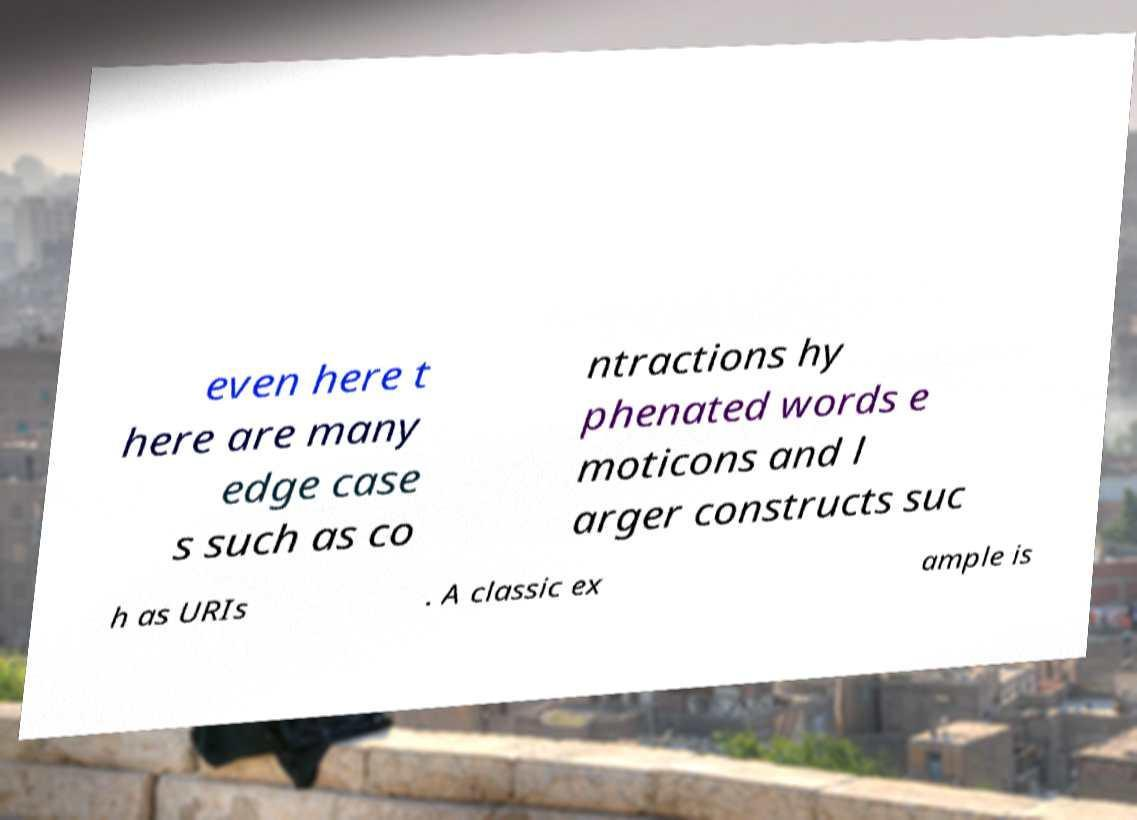I need the written content from this picture converted into text. Can you do that? even here t here are many edge case s such as co ntractions hy phenated words e moticons and l arger constructs suc h as URIs . A classic ex ample is 